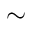Convert formula to latex. <formula><loc_0><loc_0><loc_500><loc_500>\sim</formula> 